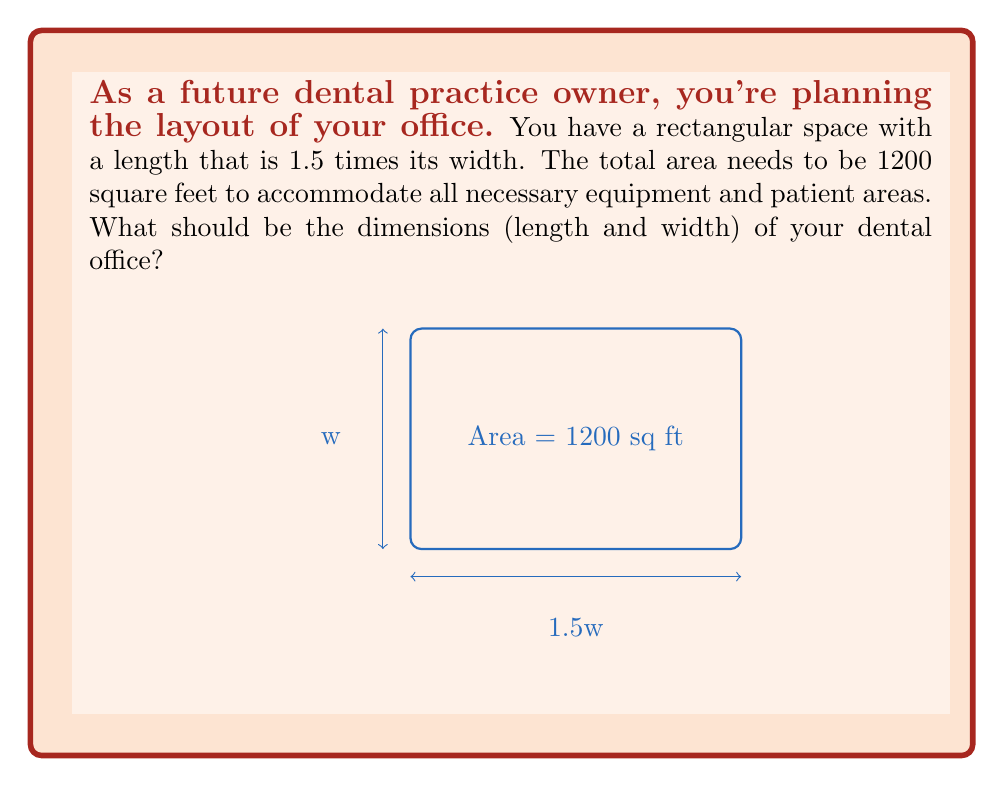Solve this math problem. Let's approach this step-by-step:

1) Let the width of the office be $w$ feet. Then, the length is $1.5w$ feet.

2) The area of a rectangle is given by length × width. So we can set up the equation:

   $$ \text{Area} = \text{length} \times \text{width} $$
   $$ 1200 = 1.5w \times w $$

3) Simplify the right side of the equation:
   $$ 1200 = 1.5w^2 $$

4) Divide both sides by 1.5:
   $$ 800 = w^2 $$

5) Take the square root of both sides:
   $$ \sqrt{800} = w $$
   $$ w \approx 28.28 \text{ feet} $$

6) Now that we have the width, we can calculate the length:
   $$ \text{length} = 1.5w = 1.5 \times 28.28 \approx 42.43 \text{ feet} $$

7) Rounding to the nearest foot for practical purposes:
   Width ≈ 28 feet
   Length ≈ 42 feet
Answer: 28 ft × 42 ft 